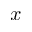<formula> <loc_0><loc_0><loc_500><loc_500>x</formula> 